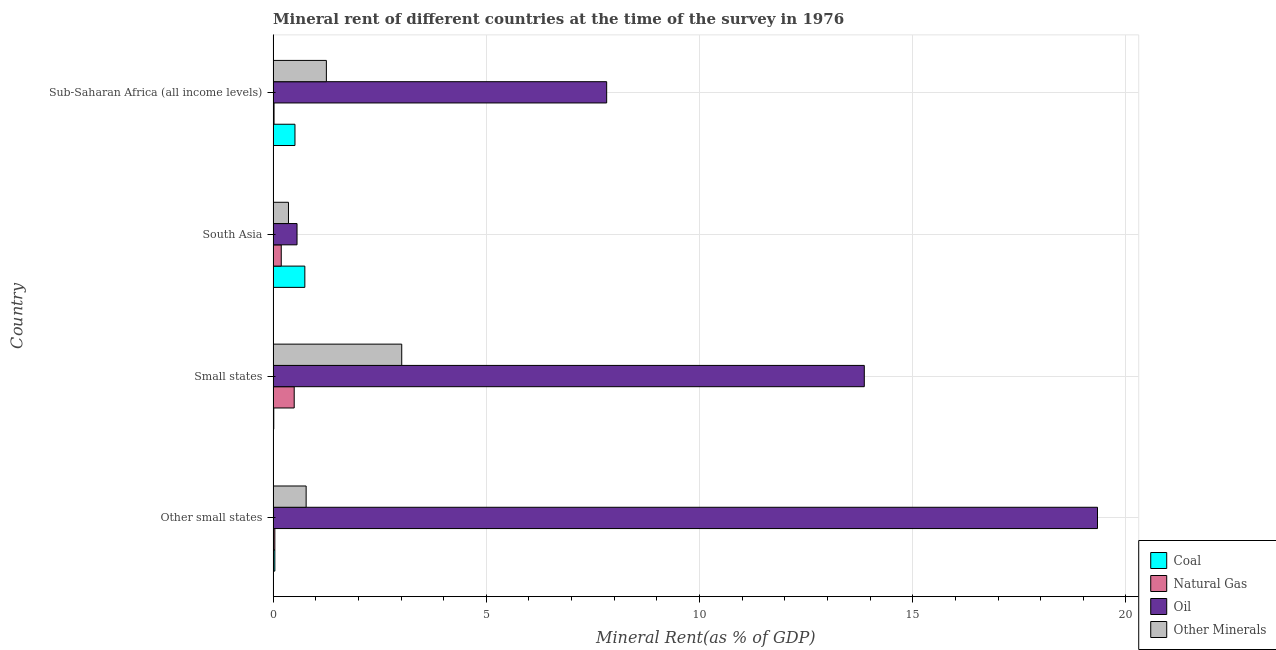How many groups of bars are there?
Provide a short and direct response. 4. Are the number of bars per tick equal to the number of legend labels?
Offer a terse response. Yes. Are the number of bars on each tick of the Y-axis equal?
Your answer should be compact. Yes. What is the label of the 3rd group of bars from the top?
Make the answer very short. Small states. In how many cases, is the number of bars for a given country not equal to the number of legend labels?
Keep it short and to the point. 0. What is the natural gas rent in Other small states?
Keep it short and to the point. 0.04. Across all countries, what is the maximum oil rent?
Your answer should be compact. 19.33. Across all countries, what is the minimum oil rent?
Your answer should be compact. 0.56. In which country was the natural gas rent maximum?
Your answer should be very brief. Small states. In which country was the natural gas rent minimum?
Offer a very short reply. Sub-Saharan Africa (all income levels). What is the total natural gas rent in the graph?
Keep it short and to the point. 0.75. What is the difference between the coal rent in Small states and that in Sub-Saharan Africa (all income levels)?
Make the answer very short. -0.5. What is the difference between the oil rent in South Asia and the  rent of other minerals in Small states?
Keep it short and to the point. -2.46. What is the average coal rent per country?
Your answer should be very brief. 0.33. What is the difference between the  rent of other minerals and coal rent in South Asia?
Your answer should be very brief. -0.38. Is the difference between the  rent of other minerals in Small states and Sub-Saharan Africa (all income levels) greater than the difference between the oil rent in Small states and Sub-Saharan Africa (all income levels)?
Offer a very short reply. No. What is the difference between the highest and the second highest natural gas rent?
Give a very brief answer. 0.3. What is the difference between the highest and the lowest oil rent?
Ensure brevity in your answer.  18.77. Is it the case that in every country, the sum of the  rent of other minerals and coal rent is greater than the sum of natural gas rent and oil rent?
Offer a very short reply. No. What does the 3rd bar from the top in Small states represents?
Offer a very short reply. Natural Gas. What does the 2nd bar from the bottom in Sub-Saharan Africa (all income levels) represents?
Your response must be concise. Natural Gas. Is it the case that in every country, the sum of the coal rent and natural gas rent is greater than the oil rent?
Give a very brief answer. No. How many bars are there?
Make the answer very short. 16. How many legend labels are there?
Offer a terse response. 4. How are the legend labels stacked?
Provide a succinct answer. Vertical. What is the title of the graph?
Your answer should be very brief. Mineral rent of different countries at the time of the survey in 1976. Does "WFP" appear as one of the legend labels in the graph?
Keep it short and to the point. No. What is the label or title of the X-axis?
Ensure brevity in your answer.  Mineral Rent(as % of GDP). What is the label or title of the Y-axis?
Make the answer very short. Country. What is the Mineral Rent(as % of GDP) of Coal in Other small states?
Your answer should be very brief. 0.04. What is the Mineral Rent(as % of GDP) of Natural Gas in Other small states?
Make the answer very short. 0.04. What is the Mineral Rent(as % of GDP) of Oil in Other small states?
Offer a terse response. 19.33. What is the Mineral Rent(as % of GDP) in Other Minerals in Other small states?
Make the answer very short. 0.77. What is the Mineral Rent(as % of GDP) in Coal in Small states?
Offer a terse response. 0.02. What is the Mineral Rent(as % of GDP) in Natural Gas in Small states?
Ensure brevity in your answer.  0.49. What is the Mineral Rent(as % of GDP) in Oil in Small states?
Provide a short and direct response. 13.86. What is the Mineral Rent(as % of GDP) of Other Minerals in Small states?
Make the answer very short. 3.02. What is the Mineral Rent(as % of GDP) of Coal in South Asia?
Offer a very short reply. 0.74. What is the Mineral Rent(as % of GDP) in Natural Gas in South Asia?
Your answer should be very brief. 0.19. What is the Mineral Rent(as % of GDP) in Oil in South Asia?
Provide a short and direct response. 0.56. What is the Mineral Rent(as % of GDP) of Other Minerals in South Asia?
Provide a succinct answer. 0.36. What is the Mineral Rent(as % of GDP) in Coal in Sub-Saharan Africa (all income levels)?
Give a very brief answer. 0.51. What is the Mineral Rent(as % of GDP) of Natural Gas in Sub-Saharan Africa (all income levels)?
Your answer should be compact. 0.02. What is the Mineral Rent(as % of GDP) in Oil in Sub-Saharan Africa (all income levels)?
Give a very brief answer. 7.82. What is the Mineral Rent(as % of GDP) of Other Minerals in Sub-Saharan Africa (all income levels)?
Give a very brief answer. 1.25. Across all countries, what is the maximum Mineral Rent(as % of GDP) of Coal?
Ensure brevity in your answer.  0.74. Across all countries, what is the maximum Mineral Rent(as % of GDP) in Natural Gas?
Your answer should be compact. 0.49. Across all countries, what is the maximum Mineral Rent(as % of GDP) in Oil?
Offer a very short reply. 19.33. Across all countries, what is the maximum Mineral Rent(as % of GDP) of Other Minerals?
Offer a terse response. 3.02. Across all countries, what is the minimum Mineral Rent(as % of GDP) of Coal?
Make the answer very short. 0.02. Across all countries, what is the minimum Mineral Rent(as % of GDP) in Natural Gas?
Provide a succinct answer. 0.02. Across all countries, what is the minimum Mineral Rent(as % of GDP) in Oil?
Your answer should be very brief. 0.56. Across all countries, what is the minimum Mineral Rent(as % of GDP) of Other Minerals?
Make the answer very short. 0.36. What is the total Mineral Rent(as % of GDP) in Coal in the graph?
Keep it short and to the point. 1.31. What is the total Mineral Rent(as % of GDP) in Natural Gas in the graph?
Keep it short and to the point. 0.75. What is the total Mineral Rent(as % of GDP) in Oil in the graph?
Provide a short and direct response. 41.58. What is the total Mineral Rent(as % of GDP) in Other Minerals in the graph?
Offer a terse response. 5.4. What is the difference between the Mineral Rent(as % of GDP) of Coal in Other small states and that in Small states?
Offer a very short reply. 0.03. What is the difference between the Mineral Rent(as % of GDP) in Natural Gas in Other small states and that in Small states?
Provide a succinct answer. -0.45. What is the difference between the Mineral Rent(as % of GDP) in Oil in Other small states and that in Small states?
Give a very brief answer. 5.47. What is the difference between the Mineral Rent(as % of GDP) in Other Minerals in Other small states and that in Small states?
Your response must be concise. -2.24. What is the difference between the Mineral Rent(as % of GDP) in Coal in Other small states and that in South Asia?
Provide a short and direct response. -0.7. What is the difference between the Mineral Rent(as % of GDP) in Oil in Other small states and that in South Asia?
Give a very brief answer. 18.77. What is the difference between the Mineral Rent(as % of GDP) of Other Minerals in Other small states and that in South Asia?
Keep it short and to the point. 0.41. What is the difference between the Mineral Rent(as % of GDP) of Coal in Other small states and that in Sub-Saharan Africa (all income levels)?
Provide a short and direct response. -0.47. What is the difference between the Mineral Rent(as % of GDP) of Natural Gas in Other small states and that in Sub-Saharan Africa (all income levels)?
Make the answer very short. 0.02. What is the difference between the Mineral Rent(as % of GDP) of Oil in Other small states and that in Sub-Saharan Africa (all income levels)?
Provide a succinct answer. 11.51. What is the difference between the Mineral Rent(as % of GDP) of Other Minerals in Other small states and that in Sub-Saharan Africa (all income levels)?
Your answer should be compact. -0.47. What is the difference between the Mineral Rent(as % of GDP) of Coal in Small states and that in South Asia?
Provide a short and direct response. -0.73. What is the difference between the Mineral Rent(as % of GDP) in Natural Gas in Small states and that in South Asia?
Offer a terse response. 0.3. What is the difference between the Mineral Rent(as % of GDP) in Oil in Small states and that in South Asia?
Offer a very short reply. 13.3. What is the difference between the Mineral Rent(as % of GDP) of Other Minerals in Small states and that in South Asia?
Your answer should be compact. 2.66. What is the difference between the Mineral Rent(as % of GDP) in Coal in Small states and that in Sub-Saharan Africa (all income levels)?
Give a very brief answer. -0.5. What is the difference between the Mineral Rent(as % of GDP) in Natural Gas in Small states and that in Sub-Saharan Africa (all income levels)?
Offer a very short reply. 0.47. What is the difference between the Mineral Rent(as % of GDP) of Oil in Small states and that in Sub-Saharan Africa (all income levels)?
Your response must be concise. 6.04. What is the difference between the Mineral Rent(as % of GDP) in Other Minerals in Small states and that in Sub-Saharan Africa (all income levels)?
Offer a terse response. 1.77. What is the difference between the Mineral Rent(as % of GDP) in Coal in South Asia and that in Sub-Saharan Africa (all income levels)?
Your response must be concise. 0.23. What is the difference between the Mineral Rent(as % of GDP) of Natural Gas in South Asia and that in Sub-Saharan Africa (all income levels)?
Keep it short and to the point. 0.17. What is the difference between the Mineral Rent(as % of GDP) in Oil in South Asia and that in Sub-Saharan Africa (all income levels)?
Make the answer very short. -7.26. What is the difference between the Mineral Rent(as % of GDP) of Other Minerals in South Asia and that in Sub-Saharan Africa (all income levels)?
Offer a very short reply. -0.89. What is the difference between the Mineral Rent(as % of GDP) of Coal in Other small states and the Mineral Rent(as % of GDP) of Natural Gas in Small states?
Provide a succinct answer. -0.45. What is the difference between the Mineral Rent(as % of GDP) in Coal in Other small states and the Mineral Rent(as % of GDP) in Oil in Small states?
Ensure brevity in your answer.  -13.82. What is the difference between the Mineral Rent(as % of GDP) in Coal in Other small states and the Mineral Rent(as % of GDP) in Other Minerals in Small states?
Keep it short and to the point. -2.98. What is the difference between the Mineral Rent(as % of GDP) in Natural Gas in Other small states and the Mineral Rent(as % of GDP) in Oil in Small states?
Offer a very short reply. -13.82. What is the difference between the Mineral Rent(as % of GDP) of Natural Gas in Other small states and the Mineral Rent(as % of GDP) of Other Minerals in Small states?
Make the answer very short. -2.98. What is the difference between the Mineral Rent(as % of GDP) of Oil in Other small states and the Mineral Rent(as % of GDP) of Other Minerals in Small states?
Make the answer very short. 16.32. What is the difference between the Mineral Rent(as % of GDP) in Coal in Other small states and the Mineral Rent(as % of GDP) in Natural Gas in South Asia?
Make the answer very short. -0.15. What is the difference between the Mineral Rent(as % of GDP) of Coal in Other small states and the Mineral Rent(as % of GDP) of Oil in South Asia?
Your answer should be compact. -0.52. What is the difference between the Mineral Rent(as % of GDP) of Coal in Other small states and the Mineral Rent(as % of GDP) of Other Minerals in South Asia?
Provide a succinct answer. -0.32. What is the difference between the Mineral Rent(as % of GDP) of Natural Gas in Other small states and the Mineral Rent(as % of GDP) of Oil in South Asia?
Your answer should be compact. -0.52. What is the difference between the Mineral Rent(as % of GDP) in Natural Gas in Other small states and the Mineral Rent(as % of GDP) in Other Minerals in South Asia?
Your answer should be very brief. -0.32. What is the difference between the Mineral Rent(as % of GDP) in Oil in Other small states and the Mineral Rent(as % of GDP) in Other Minerals in South Asia?
Ensure brevity in your answer.  18.97. What is the difference between the Mineral Rent(as % of GDP) in Coal in Other small states and the Mineral Rent(as % of GDP) in Natural Gas in Sub-Saharan Africa (all income levels)?
Provide a short and direct response. 0.02. What is the difference between the Mineral Rent(as % of GDP) in Coal in Other small states and the Mineral Rent(as % of GDP) in Oil in Sub-Saharan Africa (all income levels)?
Offer a very short reply. -7.78. What is the difference between the Mineral Rent(as % of GDP) of Coal in Other small states and the Mineral Rent(as % of GDP) of Other Minerals in Sub-Saharan Africa (all income levels)?
Provide a succinct answer. -1.21. What is the difference between the Mineral Rent(as % of GDP) in Natural Gas in Other small states and the Mineral Rent(as % of GDP) in Oil in Sub-Saharan Africa (all income levels)?
Offer a very short reply. -7.78. What is the difference between the Mineral Rent(as % of GDP) in Natural Gas in Other small states and the Mineral Rent(as % of GDP) in Other Minerals in Sub-Saharan Africa (all income levels)?
Ensure brevity in your answer.  -1.21. What is the difference between the Mineral Rent(as % of GDP) of Oil in Other small states and the Mineral Rent(as % of GDP) of Other Minerals in Sub-Saharan Africa (all income levels)?
Your answer should be very brief. 18.08. What is the difference between the Mineral Rent(as % of GDP) of Coal in Small states and the Mineral Rent(as % of GDP) of Natural Gas in South Asia?
Provide a short and direct response. -0.18. What is the difference between the Mineral Rent(as % of GDP) of Coal in Small states and the Mineral Rent(as % of GDP) of Oil in South Asia?
Provide a short and direct response. -0.55. What is the difference between the Mineral Rent(as % of GDP) of Coal in Small states and the Mineral Rent(as % of GDP) of Other Minerals in South Asia?
Ensure brevity in your answer.  -0.34. What is the difference between the Mineral Rent(as % of GDP) of Natural Gas in Small states and the Mineral Rent(as % of GDP) of Oil in South Asia?
Offer a terse response. -0.07. What is the difference between the Mineral Rent(as % of GDP) in Natural Gas in Small states and the Mineral Rent(as % of GDP) in Other Minerals in South Asia?
Give a very brief answer. 0.13. What is the difference between the Mineral Rent(as % of GDP) of Oil in Small states and the Mineral Rent(as % of GDP) of Other Minerals in South Asia?
Keep it short and to the point. 13.5. What is the difference between the Mineral Rent(as % of GDP) in Coal in Small states and the Mineral Rent(as % of GDP) in Natural Gas in Sub-Saharan Africa (all income levels)?
Offer a very short reply. -0.01. What is the difference between the Mineral Rent(as % of GDP) of Coal in Small states and the Mineral Rent(as % of GDP) of Oil in Sub-Saharan Africa (all income levels)?
Offer a terse response. -7.81. What is the difference between the Mineral Rent(as % of GDP) of Coal in Small states and the Mineral Rent(as % of GDP) of Other Minerals in Sub-Saharan Africa (all income levels)?
Make the answer very short. -1.23. What is the difference between the Mineral Rent(as % of GDP) in Natural Gas in Small states and the Mineral Rent(as % of GDP) in Oil in Sub-Saharan Africa (all income levels)?
Your answer should be very brief. -7.33. What is the difference between the Mineral Rent(as % of GDP) in Natural Gas in Small states and the Mineral Rent(as % of GDP) in Other Minerals in Sub-Saharan Africa (all income levels)?
Keep it short and to the point. -0.75. What is the difference between the Mineral Rent(as % of GDP) of Oil in Small states and the Mineral Rent(as % of GDP) of Other Minerals in Sub-Saharan Africa (all income levels)?
Give a very brief answer. 12.62. What is the difference between the Mineral Rent(as % of GDP) of Coal in South Asia and the Mineral Rent(as % of GDP) of Natural Gas in Sub-Saharan Africa (all income levels)?
Offer a terse response. 0.72. What is the difference between the Mineral Rent(as % of GDP) in Coal in South Asia and the Mineral Rent(as % of GDP) in Oil in Sub-Saharan Africa (all income levels)?
Offer a terse response. -7.08. What is the difference between the Mineral Rent(as % of GDP) of Coal in South Asia and the Mineral Rent(as % of GDP) of Other Minerals in Sub-Saharan Africa (all income levels)?
Make the answer very short. -0.51. What is the difference between the Mineral Rent(as % of GDP) of Natural Gas in South Asia and the Mineral Rent(as % of GDP) of Oil in Sub-Saharan Africa (all income levels)?
Your answer should be very brief. -7.63. What is the difference between the Mineral Rent(as % of GDP) of Natural Gas in South Asia and the Mineral Rent(as % of GDP) of Other Minerals in Sub-Saharan Africa (all income levels)?
Make the answer very short. -1.06. What is the difference between the Mineral Rent(as % of GDP) in Oil in South Asia and the Mineral Rent(as % of GDP) in Other Minerals in Sub-Saharan Africa (all income levels)?
Your response must be concise. -0.69. What is the average Mineral Rent(as % of GDP) in Coal per country?
Make the answer very short. 0.33. What is the average Mineral Rent(as % of GDP) in Natural Gas per country?
Your answer should be very brief. 0.19. What is the average Mineral Rent(as % of GDP) in Oil per country?
Make the answer very short. 10.39. What is the average Mineral Rent(as % of GDP) in Other Minerals per country?
Make the answer very short. 1.35. What is the difference between the Mineral Rent(as % of GDP) of Coal and Mineral Rent(as % of GDP) of Natural Gas in Other small states?
Your answer should be very brief. -0. What is the difference between the Mineral Rent(as % of GDP) of Coal and Mineral Rent(as % of GDP) of Oil in Other small states?
Your response must be concise. -19.29. What is the difference between the Mineral Rent(as % of GDP) of Coal and Mineral Rent(as % of GDP) of Other Minerals in Other small states?
Offer a terse response. -0.73. What is the difference between the Mineral Rent(as % of GDP) in Natural Gas and Mineral Rent(as % of GDP) in Oil in Other small states?
Make the answer very short. -19.29. What is the difference between the Mineral Rent(as % of GDP) of Natural Gas and Mineral Rent(as % of GDP) of Other Minerals in Other small states?
Ensure brevity in your answer.  -0.73. What is the difference between the Mineral Rent(as % of GDP) in Oil and Mineral Rent(as % of GDP) in Other Minerals in Other small states?
Keep it short and to the point. 18.56. What is the difference between the Mineral Rent(as % of GDP) of Coal and Mineral Rent(as % of GDP) of Natural Gas in Small states?
Your answer should be very brief. -0.48. What is the difference between the Mineral Rent(as % of GDP) of Coal and Mineral Rent(as % of GDP) of Oil in Small states?
Make the answer very short. -13.85. What is the difference between the Mineral Rent(as % of GDP) in Coal and Mineral Rent(as % of GDP) in Other Minerals in Small states?
Make the answer very short. -3. What is the difference between the Mineral Rent(as % of GDP) in Natural Gas and Mineral Rent(as % of GDP) in Oil in Small states?
Your answer should be compact. -13.37. What is the difference between the Mineral Rent(as % of GDP) in Natural Gas and Mineral Rent(as % of GDP) in Other Minerals in Small states?
Your answer should be compact. -2.52. What is the difference between the Mineral Rent(as % of GDP) in Oil and Mineral Rent(as % of GDP) in Other Minerals in Small states?
Offer a very short reply. 10.85. What is the difference between the Mineral Rent(as % of GDP) in Coal and Mineral Rent(as % of GDP) in Natural Gas in South Asia?
Make the answer very short. 0.55. What is the difference between the Mineral Rent(as % of GDP) in Coal and Mineral Rent(as % of GDP) in Oil in South Asia?
Ensure brevity in your answer.  0.18. What is the difference between the Mineral Rent(as % of GDP) in Coal and Mineral Rent(as % of GDP) in Other Minerals in South Asia?
Make the answer very short. 0.38. What is the difference between the Mineral Rent(as % of GDP) of Natural Gas and Mineral Rent(as % of GDP) of Oil in South Asia?
Your answer should be compact. -0.37. What is the difference between the Mineral Rent(as % of GDP) in Natural Gas and Mineral Rent(as % of GDP) in Other Minerals in South Asia?
Your answer should be very brief. -0.17. What is the difference between the Mineral Rent(as % of GDP) in Oil and Mineral Rent(as % of GDP) in Other Minerals in South Asia?
Ensure brevity in your answer.  0.2. What is the difference between the Mineral Rent(as % of GDP) in Coal and Mineral Rent(as % of GDP) in Natural Gas in Sub-Saharan Africa (all income levels)?
Keep it short and to the point. 0.49. What is the difference between the Mineral Rent(as % of GDP) in Coal and Mineral Rent(as % of GDP) in Oil in Sub-Saharan Africa (all income levels)?
Make the answer very short. -7.31. What is the difference between the Mineral Rent(as % of GDP) of Coal and Mineral Rent(as % of GDP) of Other Minerals in Sub-Saharan Africa (all income levels)?
Offer a terse response. -0.74. What is the difference between the Mineral Rent(as % of GDP) in Natural Gas and Mineral Rent(as % of GDP) in Oil in Sub-Saharan Africa (all income levels)?
Provide a short and direct response. -7.8. What is the difference between the Mineral Rent(as % of GDP) in Natural Gas and Mineral Rent(as % of GDP) in Other Minerals in Sub-Saharan Africa (all income levels)?
Your answer should be very brief. -1.23. What is the difference between the Mineral Rent(as % of GDP) of Oil and Mineral Rent(as % of GDP) of Other Minerals in Sub-Saharan Africa (all income levels)?
Provide a succinct answer. 6.57. What is the ratio of the Mineral Rent(as % of GDP) of Coal in Other small states to that in Small states?
Keep it short and to the point. 2.65. What is the ratio of the Mineral Rent(as % of GDP) of Natural Gas in Other small states to that in Small states?
Your answer should be compact. 0.08. What is the ratio of the Mineral Rent(as % of GDP) in Oil in Other small states to that in Small states?
Your response must be concise. 1.39. What is the ratio of the Mineral Rent(as % of GDP) in Other Minerals in Other small states to that in Small states?
Give a very brief answer. 0.26. What is the ratio of the Mineral Rent(as % of GDP) in Coal in Other small states to that in South Asia?
Provide a short and direct response. 0.05. What is the ratio of the Mineral Rent(as % of GDP) of Natural Gas in Other small states to that in South Asia?
Provide a short and direct response. 0.21. What is the ratio of the Mineral Rent(as % of GDP) in Oil in Other small states to that in South Asia?
Provide a succinct answer. 34.48. What is the ratio of the Mineral Rent(as % of GDP) in Other Minerals in Other small states to that in South Asia?
Provide a short and direct response. 2.15. What is the ratio of the Mineral Rent(as % of GDP) of Coal in Other small states to that in Sub-Saharan Africa (all income levels)?
Your answer should be compact. 0.08. What is the ratio of the Mineral Rent(as % of GDP) of Natural Gas in Other small states to that in Sub-Saharan Africa (all income levels)?
Your answer should be compact. 1.85. What is the ratio of the Mineral Rent(as % of GDP) in Oil in Other small states to that in Sub-Saharan Africa (all income levels)?
Offer a very short reply. 2.47. What is the ratio of the Mineral Rent(as % of GDP) of Other Minerals in Other small states to that in Sub-Saharan Africa (all income levels)?
Your response must be concise. 0.62. What is the ratio of the Mineral Rent(as % of GDP) in Coal in Small states to that in South Asia?
Give a very brief answer. 0.02. What is the ratio of the Mineral Rent(as % of GDP) in Natural Gas in Small states to that in South Asia?
Give a very brief answer. 2.6. What is the ratio of the Mineral Rent(as % of GDP) of Oil in Small states to that in South Asia?
Keep it short and to the point. 24.73. What is the ratio of the Mineral Rent(as % of GDP) of Other Minerals in Small states to that in South Asia?
Give a very brief answer. 8.38. What is the ratio of the Mineral Rent(as % of GDP) of Coal in Small states to that in Sub-Saharan Africa (all income levels)?
Ensure brevity in your answer.  0.03. What is the ratio of the Mineral Rent(as % of GDP) in Natural Gas in Small states to that in Sub-Saharan Africa (all income levels)?
Give a very brief answer. 22.58. What is the ratio of the Mineral Rent(as % of GDP) in Oil in Small states to that in Sub-Saharan Africa (all income levels)?
Make the answer very short. 1.77. What is the ratio of the Mineral Rent(as % of GDP) of Other Minerals in Small states to that in Sub-Saharan Africa (all income levels)?
Your answer should be compact. 2.41. What is the ratio of the Mineral Rent(as % of GDP) of Coal in South Asia to that in Sub-Saharan Africa (all income levels)?
Ensure brevity in your answer.  1.45. What is the ratio of the Mineral Rent(as % of GDP) of Natural Gas in South Asia to that in Sub-Saharan Africa (all income levels)?
Ensure brevity in your answer.  8.7. What is the ratio of the Mineral Rent(as % of GDP) of Oil in South Asia to that in Sub-Saharan Africa (all income levels)?
Give a very brief answer. 0.07. What is the ratio of the Mineral Rent(as % of GDP) of Other Minerals in South Asia to that in Sub-Saharan Africa (all income levels)?
Give a very brief answer. 0.29. What is the difference between the highest and the second highest Mineral Rent(as % of GDP) of Coal?
Your response must be concise. 0.23. What is the difference between the highest and the second highest Mineral Rent(as % of GDP) of Natural Gas?
Provide a short and direct response. 0.3. What is the difference between the highest and the second highest Mineral Rent(as % of GDP) in Oil?
Your answer should be compact. 5.47. What is the difference between the highest and the second highest Mineral Rent(as % of GDP) of Other Minerals?
Provide a short and direct response. 1.77. What is the difference between the highest and the lowest Mineral Rent(as % of GDP) of Coal?
Provide a short and direct response. 0.73. What is the difference between the highest and the lowest Mineral Rent(as % of GDP) of Natural Gas?
Offer a terse response. 0.47. What is the difference between the highest and the lowest Mineral Rent(as % of GDP) of Oil?
Provide a short and direct response. 18.77. What is the difference between the highest and the lowest Mineral Rent(as % of GDP) of Other Minerals?
Offer a very short reply. 2.66. 